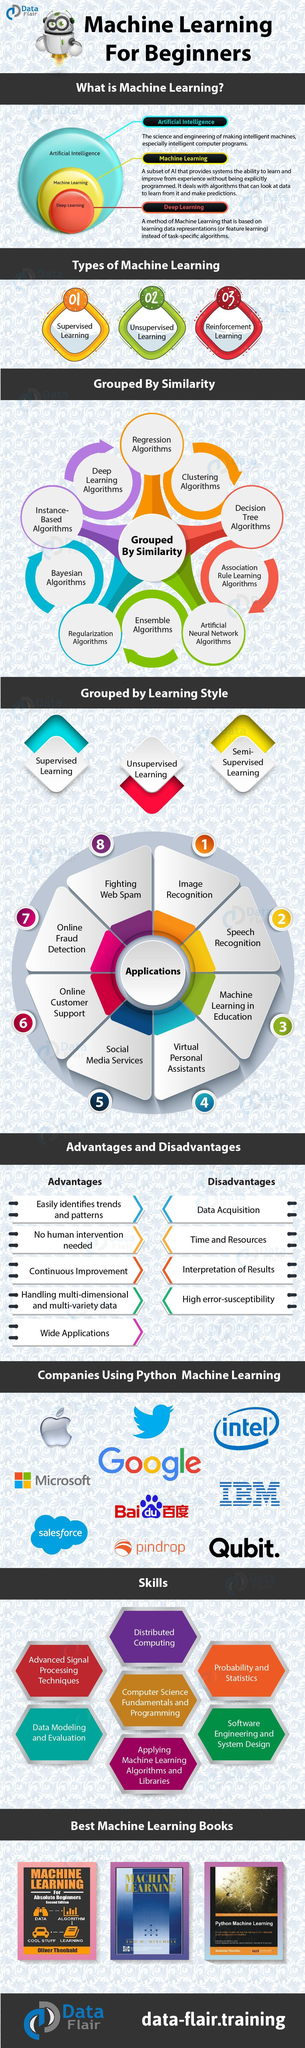Who is the author of Python Machine Learning?
Answer the question with a short phrase. Sebastian Raschka Which listed book has been authored by Oliver Theobald? MACHINE LEARNING For Absolute Beginners Which application is represented by yellow colour? Speech Recognition How many algorithms are involved in machine learning? 10 How many applications of Machine Learning are given? 8 How many types of machine learning are given? 3 